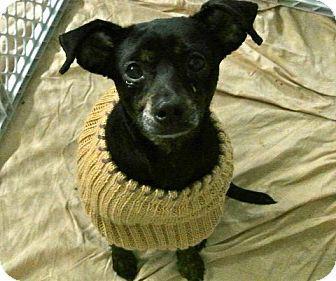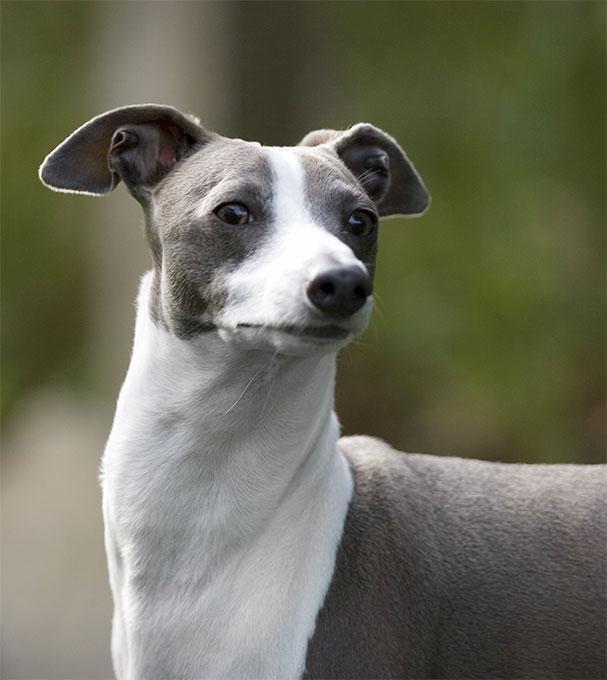The first image is the image on the left, the second image is the image on the right. Assess this claim about the two images: "The Italian Greyhound dog is standing in each image.". Correct or not? Answer yes or no. No. The first image is the image on the left, the second image is the image on the right. For the images displayed, is the sentence "There are two dogs standing and facing the same direction as the other." factually correct? Answer yes or no. No. 